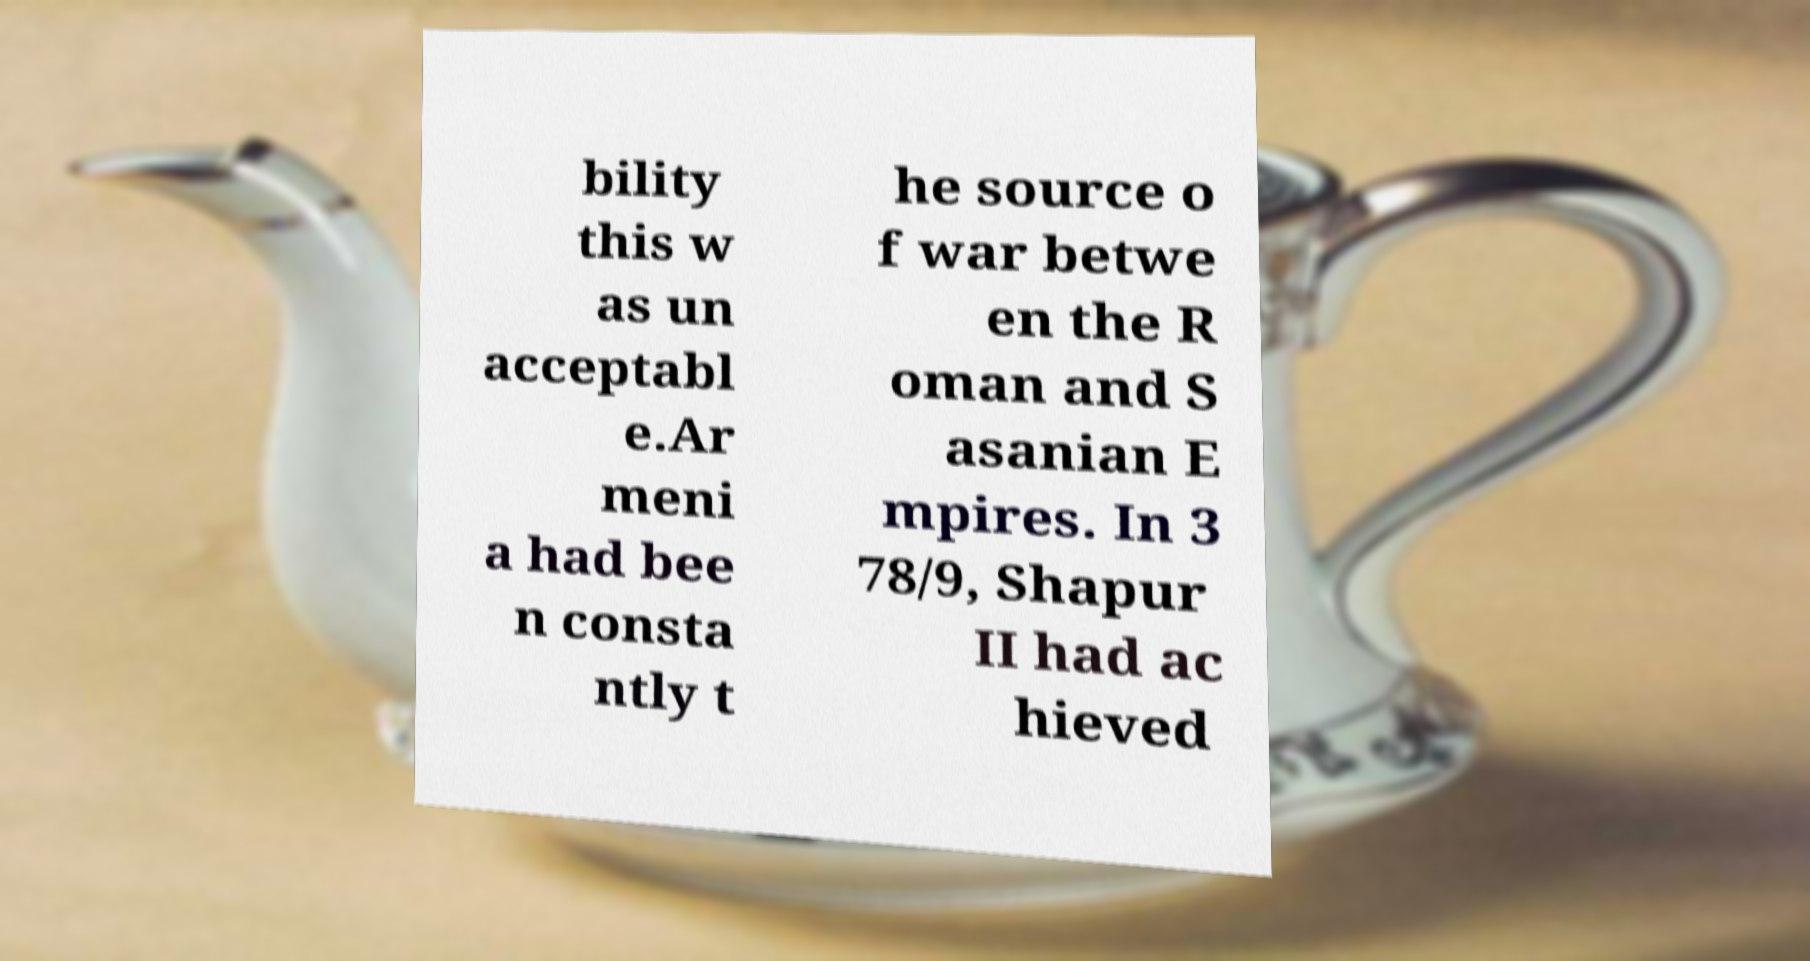Can you accurately transcribe the text from the provided image for me? bility this w as un acceptabl e.Ar meni a had bee n consta ntly t he source o f war betwe en the R oman and S asanian E mpires. In 3 78/9, Shapur II had ac hieved 